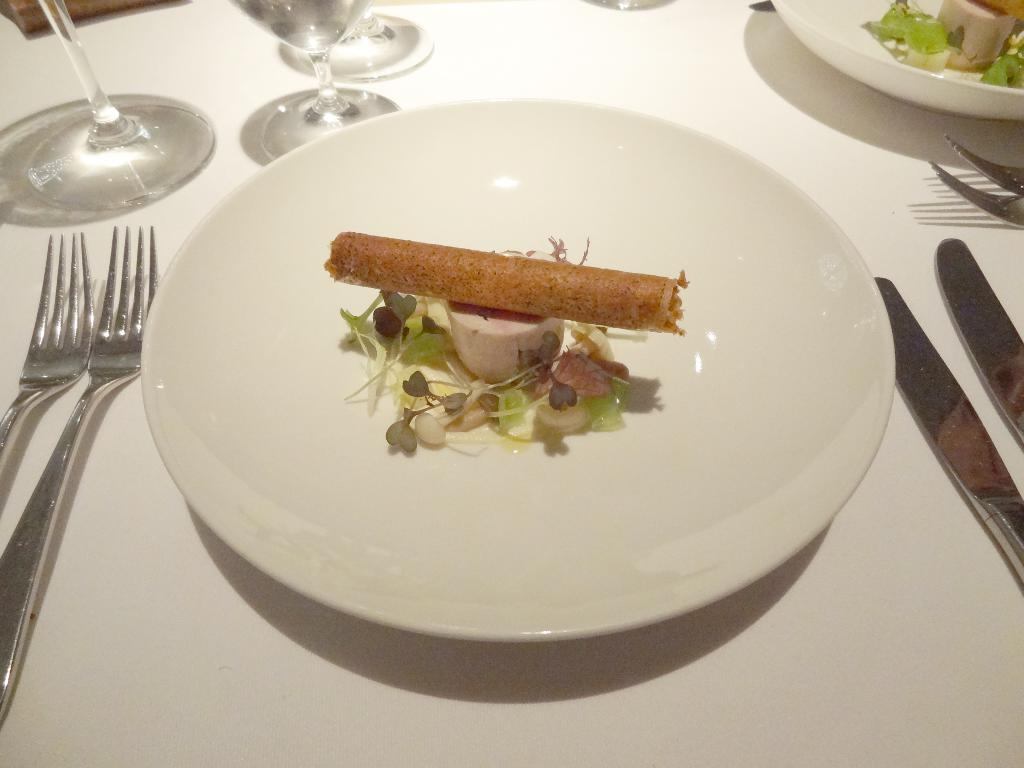What is on the white plate in the image? The plate contains leaves, flowers, cucumber, and a roll. What type of utensils are on the table? There are forks and knives on the table. What other items are on the table? There are plates and water glasses on the table, as well as other objects. What type of train is passing through the territory in the image? There is no train or territory present in the image; it features a white plate with various food items and a table with utensils and other objects. 